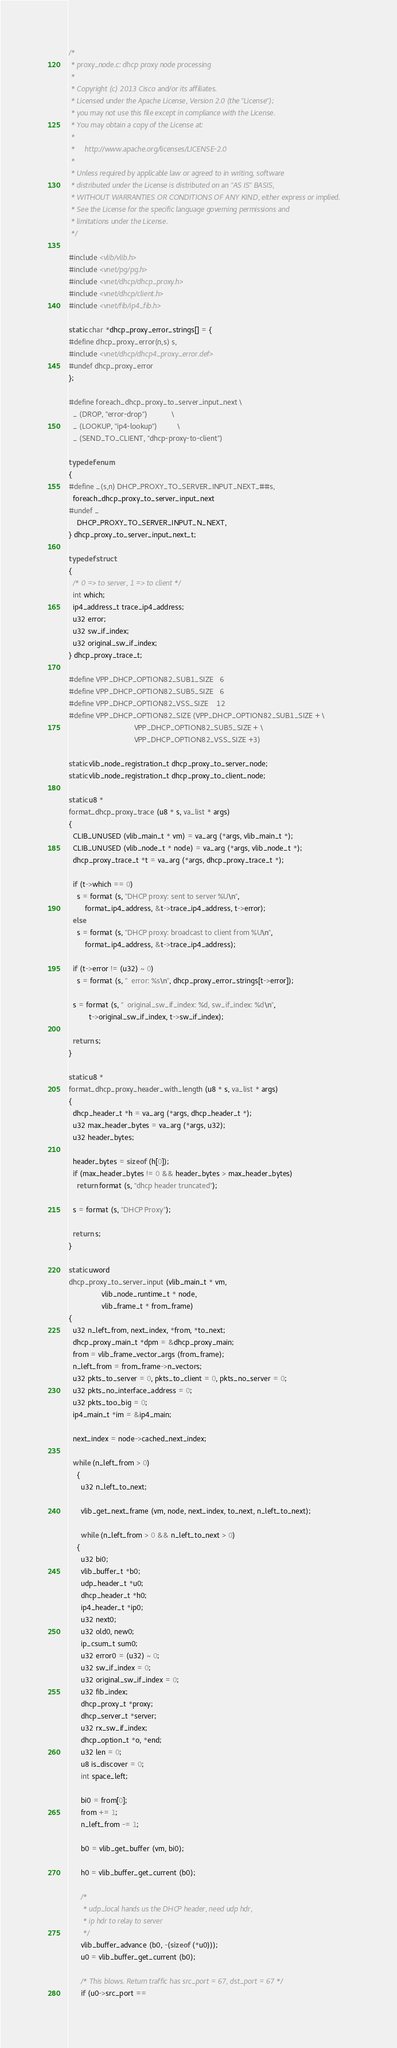Convert code to text. <code><loc_0><loc_0><loc_500><loc_500><_C_>/*
 * proxy_node.c: dhcp proxy node processing
 *
 * Copyright (c) 2013 Cisco and/or its affiliates.
 * Licensed under the Apache License, Version 2.0 (the "License");
 * you may not use this file except in compliance with the License.
 * You may obtain a copy of the License at:
 *
 *     http://www.apache.org/licenses/LICENSE-2.0
 *
 * Unless required by applicable law or agreed to in writing, software
 * distributed under the License is distributed on an "AS IS" BASIS,
 * WITHOUT WARRANTIES OR CONDITIONS OF ANY KIND, either express or implied.
 * See the License for the specific language governing permissions and
 * limitations under the License.
 */

#include <vlib/vlib.h>
#include <vnet/pg/pg.h>
#include <vnet/dhcp/dhcp_proxy.h>
#include <vnet/dhcp/client.h>
#include <vnet/fib/ip4_fib.h>

static char *dhcp_proxy_error_strings[] = {
#define dhcp_proxy_error(n,s) s,
#include <vnet/dhcp/dhcp4_proxy_error.def>
#undef dhcp_proxy_error
};

#define foreach_dhcp_proxy_to_server_input_next \
  _ (DROP, "error-drop")			\
  _ (LOOKUP, "ip4-lookup")			\
  _ (SEND_TO_CLIENT, "dhcp-proxy-to-client")

typedef enum
{
#define _(s,n) DHCP_PROXY_TO_SERVER_INPUT_NEXT_##s,
  foreach_dhcp_proxy_to_server_input_next
#undef _
    DHCP_PROXY_TO_SERVER_INPUT_N_NEXT,
} dhcp_proxy_to_server_input_next_t;

typedef struct
{
  /* 0 => to server, 1 => to client */
  int which;
  ip4_address_t trace_ip4_address;
  u32 error;
  u32 sw_if_index;
  u32 original_sw_if_index;
} dhcp_proxy_trace_t;

#define VPP_DHCP_OPTION82_SUB1_SIZE   6
#define VPP_DHCP_OPTION82_SUB5_SIZE   6
#define VPP_DHCP_OPTION82_VSS_SIZE    12
#define VPP_DHCP_OPTION82_SIZE (VPP_DHCP_OPTION82_SUB1_SIZE + \
                                VPP_DHCP_OPTION82_SUB5_SIZE + \
                                VPP_DHCP_OPTION82_VSS_SIZE +3)

static vlib_node_registration_t dhcp_proxy_to_server_node;
static vlib_node_registration_t dhcp_proxy_to_client_node;

static u8 *
format_dhcp_proxy_trace (u8 * s, va_list * args)
{
  CLIB_UNUSED (vlib_main_t * vm) = va_arg (*args, vlib_main_t *);
  CLIB_UNUSED (vlib_node_t * node) = va_arg (*args, vlib_node_t *);
  dhcp_proxy_trace_t *t = va_arg (*args, dhcp_proxy_trace_t *);

  if (t->which == 0)
    s = format (s, "DHCP proxy: sent to server %U\n",
		format_ip4_address, &t->trace_ip4_address, t->error);
  else
    s = format (s, "DHCP proxy: broadcast to client from %U\n",
		format_ip4_address, &t->trace_ip4_address);

  if (t->error != (u32) ~ 0)
    s = format (s, "  error: %s\n", dhcp_proxy_error_strings[t->error]);

  s = format (s, "  original_sw_if_index: %d, sw_if_index: %d\n",
	      t->original_sw_if_index, t->sw_if_index);

  return s;
}

static u8 *
format_dhcp_proxy_header_with_length (u8 * s, va_list * args)
{
  dhcp_header_t *h = va_arg (*args, dhcp_header_t *);
  u32 max_header_bytes = va_arg (*args, u32);
  u32 header_bytes;

  header_bytes = sizeof (h[0]);
  if (max_header_bytes != 0 && header_bytes > max_header_bytes)
    return format (s, "dhcp header truncated");

  s = format (s, "DHCP Proxy");

  return s;
}

static uword
dhcp_proxy_to_server_input (vlib_main_t * vm,
			    vlib_node_runtime_t * node,
			    vlib_frame_t * from_frame)
{
  u32 n_left_from, next_index, *from, *to_next;
  dhcp_proxy_main_t *dpm = &dhcp_proxy_main;
  from = vlib_frame_vector_args (from_frame);
  n_left_from = from_frame->n_vectors;
  u32 pkts_to_server = 0, pkts_to_client = 0, pkts_no_server = 0;
  u32 pkts_no_interface_address = 0;
  u32 pkts_too_big = 0;
  ip4_main_t *im = &ip4_main;

  next_index = node->cached_next_index;

  while (n_left_from > 0)
    {
      u32 n_left_to_next;

      vlib_get_next_frame (vm, node, next_index, to_next, n_left_to_next);

      while (n_left_from > 0 && n_left_to_next > 0)
	{
	  u32 bi0;
	  vlib_buffer_t *b0;
	  udp_header_t *u0;
	  dhcp_header_t *h0;
	  ip4_header_t *ip0;
	  u32 next0;
	  u32 old0, new0;
	  ip_csum_t sum0;
	  u32 error0 = (u32) ~ 0;
	  u32 sw_if_index = 0;
	  u32 original_sw_if_index = 0;
	  u32 fib_index;
	  dhcp_proxy_t *proxy;
	  dhcp_server_t *server;
	  u32 rx_sw_if_index;
	  dhcp_option_t *o, *end;
	  u32 len = 0;
	  u8 is_discover = 0;
	  int space_left;

	  bi0 = from[0];
	  from += 1;
	  n_left_from -= 1;

	  b0 = vlib_get_buffer (vm, bi0);

	  h0 = vlib_buffer_get_current (b0);

	  /*
	   * udp_local hands us the DHCP header, need udp hdr,
	   * ip hdr to relay to server
	   */
	  vlib_buffer_advance (b0, -(sizeof (*u0)));
	  u0 = vlib_buffer_get_current (b0);

	  /* This blows. Return traffic has src_port = 67, dst_port = 67 */
	  if (u0->src_port ==</code> 